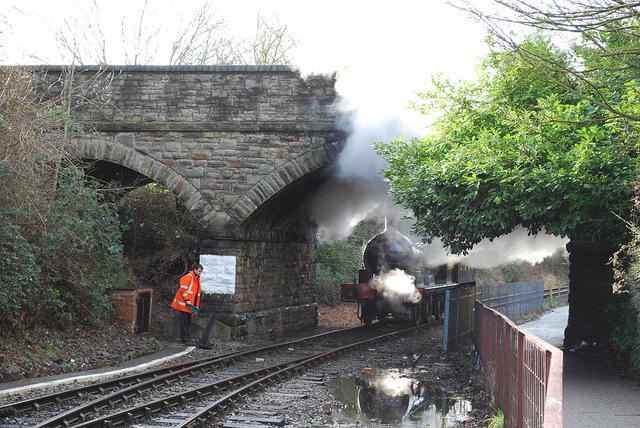Where is the man?
Be succinct. Near bridge. Is the train smoking?
Be succinct. Yes. What is the train going through?
Quick response, please. Tunnel. 